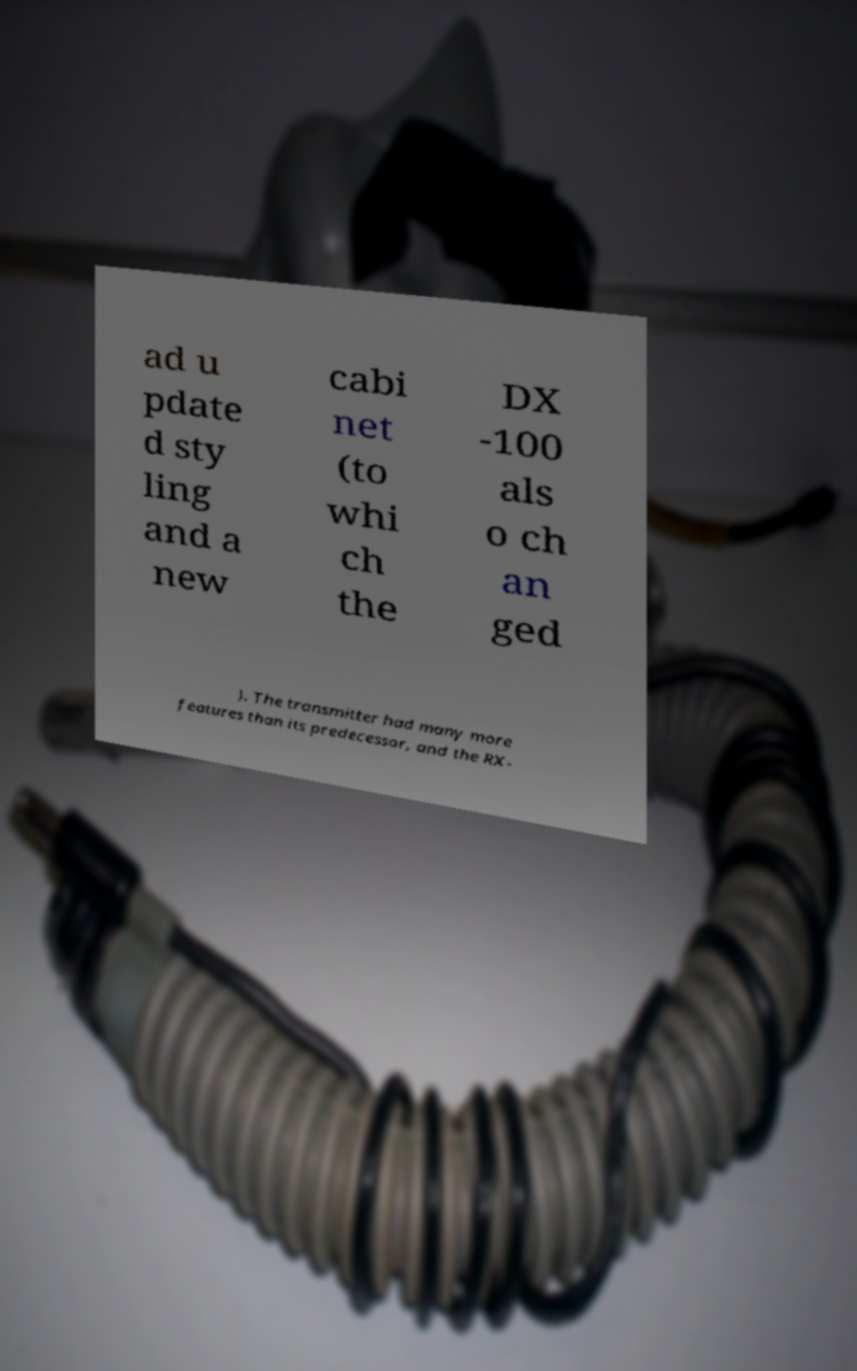Please read and relay the text visible in this image. What does it say? ad u pdate d sty ling and a new cabi net (to whi ch the DX -100 als o ch an ged ). The transmitter had many more features than its predecessor, and the RX- 